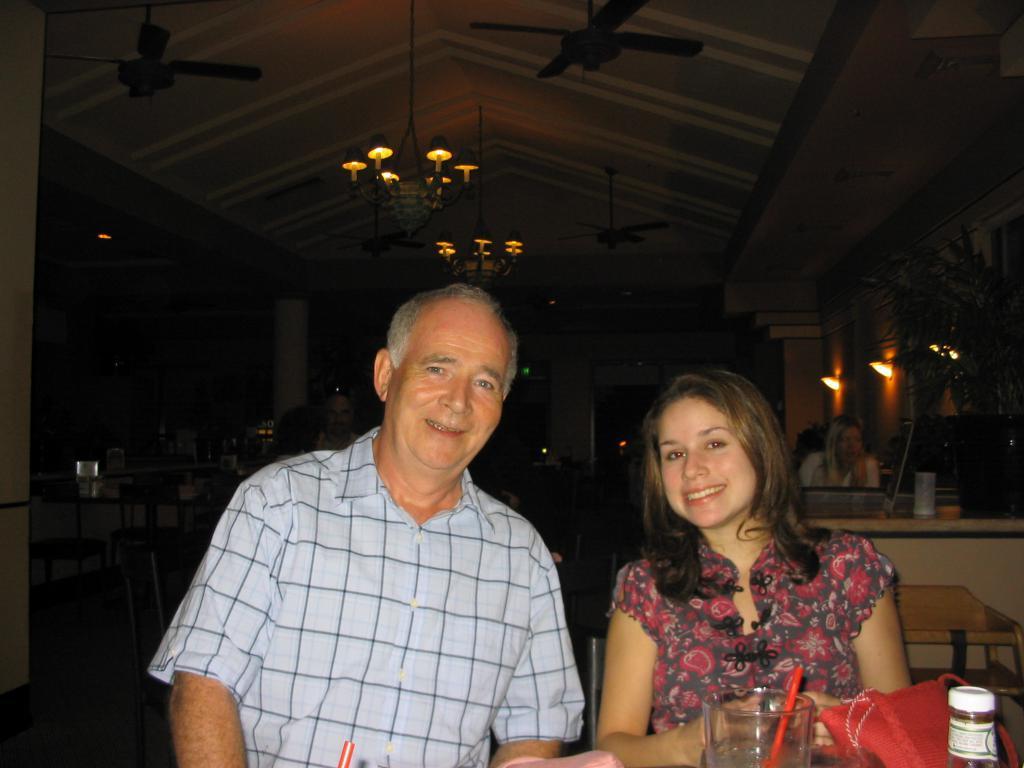In one or two sentences, can you explain what this image depicts? In this image I can see a man and a woman are sitting on chairs. Here I can see a glass and a bottle. I can also smile on their faces. In the background I can see one more person and number of chairs and tables. 